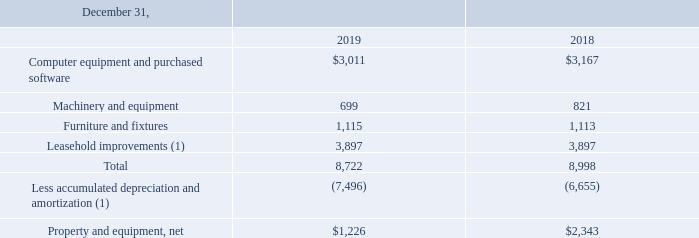Property and Equipment
Property and equipment are as follows (in thousands):
(1) In the fourth quarter 2019, the Company announced its decision to exit the San Jose California facility (“SJ Facility”) by March 31, 2020. The Company accelerated the amortization of its SJ Facility leasehold improvements over the remaining estimated life which is estimated to be through March 31, 2020. As of December 31, 2019, the net book value of the SJ Facility leasehold improvements was $0.9 million and will be fully amortized by March 31, 2020.
What is the value of Computer equipment and purchased software in 2019 and 2018 respectively?
Answer scale should be: thousand. $3,011, $3,167. What was the net book value of SJ Facility leasehold improvements in 2019? $0.9 million. What is the value of Machinery and equipment in 2019 and 2018 respectively?
Answer scale should be: thousand. 699, 821. In which year was Machinery and equipment less than 700 thousands? Locate and analyze machinery and equipment in row 4
answer: 2019. What was the average Furniture and fixtures for 2018 and 2019?
Answer scale should be: thousand. (1,115 + 1,113) / 2
Answer: 1114. What was the change in the Property and equipment, net from 2018 to 2019?
Answer scale should be: thousand. 1,226 - 2,343
Answer: -1117. 